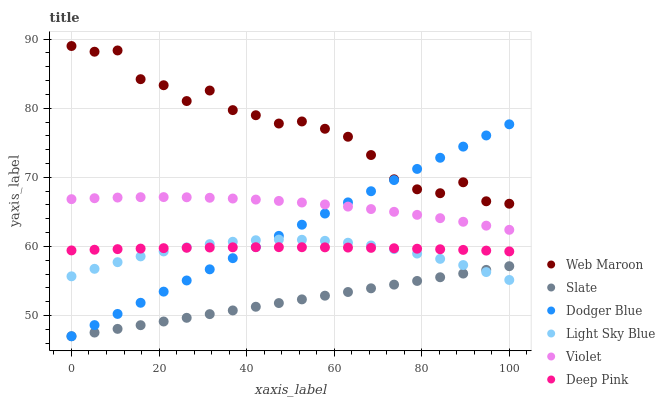Does Slate have the minimum area under the curve?
Answer yes or no. Yes. Does Web Maroon have the maximum area under the curve?
Answer yes or no. Yes. Does Web Maroon have the minimum area under the curve?
Answer yes or no. No. Does Slate have the maximum area under the curve?
Answer yes or no. No. Is Slate the smoothest?
Answer yes or no. Yes. Is Web Maroon the roughest?
Answer yes or no. Yes. Is Web Maroon the smoothest?
Answer yes or no. No. Is Slate the roughest?
Answer yes or no. No. Does Slate have the lowest value?
Answer yes or no. Yes. Does Web Maroon have the lowest value?
Answer yes or no. No. Does Web Maroon have the highest value?
Answer yes or no. Yes. Does Slate have the highest value?
Answer yes or no. No. Is Slate less than Web Maroon?
Answer yes or no. Yes. Is Violet greater than Slate?
Answer yes or no. Yes. Does Light Sky Blue intersect Slate?
Answer yes or no. Yes. Is Light Sky Blue less than Slate?
Answer yes or no. No. Is Light Sky Blue greater than Slate?
Answer yes or no. No. Does Slate intersect Web Maroon?
Answer yes or no. No. 